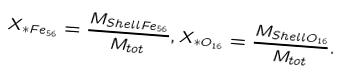<formula> <loc_0><loc_0><loc_500><loc_500>X _ { * F e _ { 5 6 } } = \frac { M _ { S h e l l F e _ { 5 6 } } } { M _ { t o t } } , X _ { * O _ { 1 6 } } = \frac { M _ { S h e l l O _ { 1 6 } } } { M _ { t o t } } .</formula> 